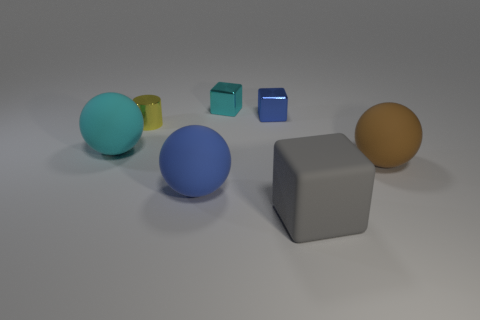Is there any other thing that is the same color as the small cylinder?
Provide a succinct answer. No. How many things are made of the same material as the blue sphere?
Offer a terse response. 3. There is a rubber thing that is right of the big cyan thing and on the left side of the gray matte thing; what is its shape?
Provide a succinct answer. Sphere. Is the blue object in front of the cyan rubber thing made of the same material as the small yellow thing?
Offer a terse response. No. What color is the cube that is the same size as the brown matte ball?
Give a very brief answer. Gray. Are there any matte cubes that have the same color as the tiny cylinder?
Give a very brief answer. No. The gray block that is made of the same material as the cyan ball is what size?
Offer a terse response. Large. What number of other objects are there of the same size as the blue metal object?
Make the answer very short. 2. There is a blue thing to the right of the large blue rubber sphere; what is it made of?
Your response must be concise. Metal. The cyan object left of the blue object that is in front of the large rubber object that is behind the brown matte object is what shape?
Your response must be concise. Sphere. 